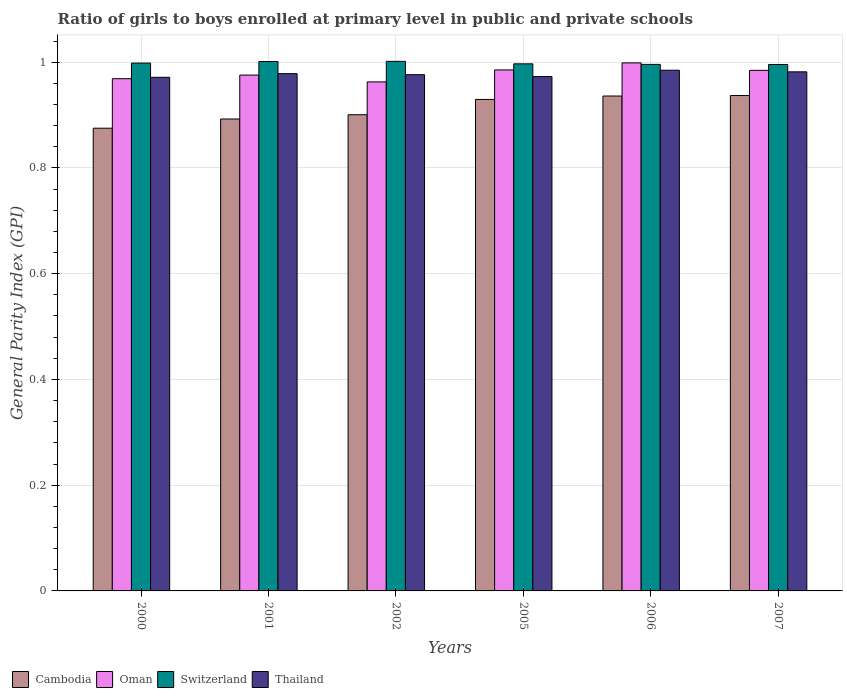How many different coloured bars are there?
Keep it short and to the point. 4. Are the number of bars per tick equal to the number of legend labels?
Your answer should be very brief. Yes. Are the number of bars on each tick of the X-axis equal?
Offer a very short reply. Yes. How many bars are there on the 3rd tick from the right?
Keep it short and to the point. 4. In how many cases, is the number of bars for a given year not equal to the number of legend labels?
Offer a very short reply. 0. What is the general parity index in Thailand in 2002?
Your answer should be compact. 0.98. Across all years, what is the maximum general parity index in Thailand?
Offer a very short reply. 0.98. Across all years, what is the minimum general parity index in Switzerland?
Your response must be concise. 1. In which year was the general parity index in Switzerland maximum?
Offer a very short reply. 2002. What is the total general parity index in Switzerland in the graph?
Keep it short and to the point. 5.99. What is the difference between the general parity index in Cambodia in 2005 and that in 2006?
Your answer should be compact. -0.01. What is the difference between the general parity index in Cambodia in 2007 and the general parity index in Thailand in 2001?
Your response must be concise. -0.04. What is the average general parity index in Cambodia per year?
Give a very brief answer. 0.91. In the year 2001, what is the difference between the general parity index in Switzerland and general parity index in Oman?
Offer a very short reply. 0.03. In how many years, is the general parity index in Thailand greater than 0.2?
Ensure brevity in your answer.  6. What is the ratio of the general parity index in Thailand in 2001 to that in 2002?
Make the answer very short. 1. What is the difference between the highest and the second highest general parity index in Oman?
Provide a short and direct response. 0.01. What is the difference between the highest and the lowest general parity index in Switzerland?
Provide a succinct answer. 0.01. In how many years, is the general parity index in Cambodia greater than the average general parity index in Cambodia taken over all years?
Your answer should be very brief. 3. Is the sum of the general parity index in Switzerland in 2002 and 2006 greater than the maximum general parity index in Cambodia across all years?
Give a very brief answer. Yes. Is it the case that in every year, the sum of the general parity index in Cambodia and general parity index in Oman is greater than the sum of general parity index in Thailand and general parity index in Switzerland?
Make the answer very short. No. What does the 1st bar from the left in 2001 represents?
Give a very brief answer. Cambodia. What does the 1st bar from the right in 2000 represents?
Make the answer very short. Thailand. How many bars are there?
Give a very brief answer. 24. Does the graph contain grids?
Make the answer very short. Yes. How are the legend labels stacked?
Provide a short and direct response. Horizontal. What is the title of the graph?
Your answer should be compact. Ratio of girls to boys enrolled at primary level in public and private schools. What is the label or title of the X-axis?
Give a very brief answer. Years. What is the label or title of the Y-axis?
Provide a short and direct response. General Parity Index (GPI). What is the General Parity Index (GPI) of Cambodia in 2000?
Ensure brevity in your answer.  0.88. What is the General Parity Index (GPI) of Oman in 2000?
Offer a terse response. 0.97. What is the General Parity Index (GPI) in Switzerland in 2000?
Your answer should be very brief. 1. What is the General Parity Index (GPI) in Thailand in 2000?
Your answer should be very brief. 0.97. What is the General Parity Index (GPI) in Cambodia in 2001?
Your answer should be compact. 0.89. What is the General Parity Index (GPI) in Oman in 2001?
Offer a terse response. 0.98. What is the General Parity Index (GPI) in Switzerland in 2001?
Ensure brevity in your answer.  1. What is the General Parity Index (GPI) in Thailand in 2001?
Your answer should be very brief. 0.98. What is the General Parity Index (GPI) of Cambodia in 2002?
Your answer should be very brief. 0.9. What is the General Parity Index (GPI) of Oman in 2002?
Provide a succinct answer. 0.96. What is the General Parity Index (GPI) of Switzerland in 2002?
Keep it short and to the point. 1. What is the General Parity Index (GPI) in Thailand in 2002?
Your answer should be very brief. 0.98. What is the General Parity Index (GPI) of Cambodia in 2005?
Ensure brevity in your answer.  0.93. What is the General Parity Index (GPI) of Oman in 2005?
Your answer should be very brief. 0.99. What is the General Parity Index (GPI) in Switzerland in 2005?
Make the answer very short. 1. What is the General Parity Index (GPI) of Thailand in 2005?
Provide a short and direct response. 0.97. What is the General Parity Index (GPI) in Cambodia in 2006?
Offer a very short reply. 0.94. What is the General Parity Index (GPI) in Oman in 2006?
Offer a very short reply. 1. What is the General Parity Index (GPI) of Switzerland in 2006?
Ensure brevity in your answer.  1. What is the General Parity Index (GPI) of Thailand in 2006?
Give a very brief answer. 0.98. What is the General Parity Index (GPI) in Cambodia in 2007?
Offer a very short reply. 0.94. What is the General Parity Index (GPI) of Oman in 2007?
Give a very brief answer. 0.98. What is the General Parity Index (GPI) in Switzerland in 2007?
Your answer should be compact. 1. What is the General Parity Index (GPI) of Thailand in 2007?
Your answer should be compact. 0.98. Across all years, what is the maximum General Parity Index (GPI) in Cambodia?
Give a very brief answer. 0.94. Across all years, what is the maximum General Parity Index (GPI) in Oman?
Offer a very short reply. 1. Across all years, what is the maximum General Parity Index (GPI) of Switzerland?
Offer a terse response. 1. Across all years, what is the maximum General Parity Index (GPI) of Thailand?
Your answer should be very brief. 0.98. Across all years, what is the minimum General Parity Index (GPI) of Cambodia?
Make the answer very short. 0.88. Across all years, what is the minimum General Parity Index (GPI) in Oman?
Your answer should be very brief. 0.96. Across all years, what is the minimum General Parity Index (GPI) in Switzerland?
Provide a succinct answer. 1. Across all years, what is the minimum General Parity Index (GPI) of Thailand?
Offer a terse response. 0.97. What is the total General Parity Index (GPI) in Cambodia in the graph?
Make the answer very short. 5.47. What is the total General Parity Index (GPI) of Oman in the graph?
Ensure brevity in your answer.  5.88. What is the total General Parity Index (GPI) in Switzerland in the graph?
Offer a terse response. 5.99. What is the total General Parity Index (GPI) in Thailand in the graph?
Provide a succinct answer. 5.87. What is the difference between the General Parity Index (GPI) in Cambodia in 2000 and that in 2001?
Offer a very short reply. -0.02. What is the difference between the General Parity Index (GPI) of Oman in 2000 and that in 2001?
Offer a very short reply. -0.01. What is the difference between the General Parity Index (GPI) of Switzerland in 2000 and that in 2001?
Offer a very short reply. -0. What is the difference between the General Parity Index (GPI) in Thailand in 2000 and that in 2001?
Your answer should be compact. -0.01. What is the difference between the General Parity Index (GPI) of Cambodia in 2000 and that in 2002?
Ensure brevity in your answer.  -0.03. What is the difference between the General Parity Index (GPI) of Oman in 2000 and that in 2002?
Provide a succinct answer. 0.01. What is the difference between the General Parity Index (GPI) of Switzerland in 2000 and that in 2002?
Your answer should be very brief. -0. What is the difference between the General Parity Index (GPI) in Thailand in 2000 and that in 2002?
Keep it short and to the point. -0.01. What is the difference between the General Parity Index (GPI) of Cambodia in 2000 and that in 2005?
Provide a succinct answer. -0.05. What is the difference between the General Parity Index (GPI) of Oman in 2000 and that in 2005?
Give a very brief answer. -0.02. What is the difference between the General Parity Index (GPI) in Switzerland in 2000 and that in 2005?
Make the answer very short. 0. What is the difference between the General Parity Index (GPI) of Thailand in 2000 and that in 2005?
Give a very brief answer. -0. What is the difference between the General Parity Index (GPI) of Cambodia in 2000 and that in 2006?
Keep it short and to the point. -0.06. What is the difference between the General Parity Index (GPI) of Oman in 2000 and that in 2006?
Keep it short and to the point. -0.03. What is the difference between the General Parity Index (GPI) in Switzerland in 2000 and that in 2006?
Give a very brief answer. 0. What is the difference between the General Parity Index (GPI) of Thailand in 2000 and that in 2006?
Your answer should be compact. -0.01. What is the difference between the General Parity Index (GPI) in Cambodia in 2000 and that in 2007?
Ensure brevity in your answer.  -0.06. What is the difference between the General Parity Index (GPI) in Oman in 2000 and that in 2007?
Your response must be concise. -0.02. What is the difference between the General Parity Index (GPI) in Switzerland in 2000 and that in 2007?
Make the answer very short. 0. What is the difference between the General Parity Index (GPI) of Thailand in 2000 and that in 2007?
Keep it short and to the point. -0.01. What is the difference between the General Parity Index (GPI) of Cambodia in 2001 and that in 2002?
Provide a succinct answer. -0.01. What is the difference between the General Parity Index (GPI) of Oman in 2001 and that in 2002?
Offer a terse response. 0.01. What is the difference between the General Parity Index (GPI) in Switzerland in 2001 and that in 2002?
Keep it short and to the point. -0. What is the difference between the General Parity Index (GPI) of Thailand in 2001 and that in 2002?
Make the answer very short. 0. What is the difference between the General Parity Index (GPI) in Cambodia in 2001 and that in 2005?
Keep it short and to the point. -0.04. What is the difference between the General Parity Index (GPI) in Oman in 2001 and that in 2005?
Provide a succinct answer. -0.01. What is the difference between the General Parity Index (GPI) in Switzerland in 2001 and that in 2005?
Your answer should be very brief. 0. What is the difference between the General Parity Index (GPI) in Thailand in 2001 and that in 2005?
Provide a short and direct response. 0.01. What is the difference between the General Parity Index (GPI) in Cambodia in 2001 and that in 2006?
Your answer should be compact. -0.04. What is the difference between the General Parity Index (GPI) of Oman in 2001 and that in 2006?
Give a very brief answer. -0.02. What is the difference between the General Parity Index (GPI) of Switzerland in 2001 and that in 2006?
Your answer should be very brief. 0.01. What is the difference between the General Parity Index (GPI) of Thailand in 2001 and that in 2006?
Keep it short and to the point. -0.01. What is the difference between the General Parity Index (GPI) of Cambodia in 2001 and that in 2007?
Your response must be concise. -0.04. What is the difference between the General Parity Index (GPI) of Oman in 2001 and that in 2007?
Provide a short and direct response. -0.01. What is the difference between the General Parity Index (GPI) in Switzerland in 2001 and that in 2007?
Keep it short and to the point. 0.01. What is the difference between the General Parity Index (GPI) of Thailand in 2001 and that in 2007?
Provide a succinct answer. -0. What is the difference between the General Parity Index (GPI) of Cambodia in 2002 and that in 2005?
Offer a terse response. -0.03. What is the difference between the General Parity Index (GPI) of Oman in 2002 and that in 2005?
Your answer should be compact. -0.02. What is the difference between the General Parity Index (GPI) in Switzerland in 2002 and that in 2005?
Your response must be concise. 0. What is the difference between the General Parity Index (GPI) of Thailand in 2002 and that in 2005?
Give a very brief answer. 0. What is the difference between the General Parity Index (GPI) in Cambodia in 2002 and that in 2006?
Give a very brief answer. -0.04. What is the difference between the General Parity Index (GPI) of Oman in 2002 and that in 2006?
Give a very brief answer. -0.04. What is the difference between the General Parity Index (GPI) in Switzerland in 2002 and that in 2006?
Give a very brief answer. 0.01. What is the difference between the General Parity Index (GPI) of Thailand in 2002 and that in 2006?
Offer a very short reply. -0.01. What is the difference between the General Parity Index (GPI) of Cambodia in 2002 and that in 2007?
Provide a succinct answer. -0.04. What is the difference between the General Parity Index (GPI) in Oman in 2002 and that in 2007?
Your answer should be compact. -0.02. What is the difference between the General Parity Index (GPI) in Switzerland in 2002 and that in 2007?
Ensure brevity in your answer.  0.01. What is the difference between the General Parity Index (GPI) in Thailand in 2002 and that in 2007?
Offer a very short reply. -0.01. What is the difference between the General Parity Index (GPI) in Cambodia in 2005 and that in 2006?
Your answer should be very brief. -0.01. What is the difference between the General Parity Index (GPI) in Oman in 2005 and that in 2006?
Offer a very short reply. -0.01. What is the difference between the General Parity Index (GPI) of Switzerland in 2005 and that in 2006?
Offer a very short reply. 0. What is the difference between the General Parity Index (GPI) of Thailand in 2005 and that in 2006?
Give a very brief answer. -0.01. What is the difference between the General Parity Index (GPI) in Cambodia in 2005 and that in 2007?
Your answer should be compact. -0.01. What is the difference between the General Parity Index (GPI) in Oman in 2005 and that in 2007?
Give a very brief answer. 0. What is the difference between the General Parity Index (GPI) of Switzerland in 2005 and that in 2007?
Your answer should be very brief. 0. What is the difference between the General Parity Index (GPI) in Thailand in 2005 and that in 2007?
Your answer should be compact. -0.01. What is the difference between the General Parity Index (GPI) of Cambodia in 2006 and that in 2007?
Your answer should be very brief. -0. What is the difference between the General Parity Index (GPI) of Oman in 2006 and that in 2007?
Make the answer very short. 0.01. What is the difference between the General Parity Index (GPI) in Thailand in 2006 and that in 2007?
Ensure brevity in your answer.  0. What is the difference between the General Parity Index (GPI) in Cambodia in 2000 and the General Parity Index (GPI) in Oman in 2001?
Your response must be concise. -0.1. What is the difference between the General Parity Index (GPI) of Cambodia in 2000 and the General Parity Index (GPI) of Switzerland in 2001?
Offer a terse response. -0.13. What is the difference between the General Parity Index (GPI) in Cambodia in 2000 and the General Parity Index (GPI) in Thailand in 2001?
Offer a terse response. -0.1. What is the difference between the General Parity Index (GPI) in Oman in 2000 and the General Parity Index (GPI) in Switzerland in 2001?
Offer a terse response. -0.03. What is the difference between the General Parity Index (GPI) in Oman in 2000 and the General Parity Index (GPI) in Thailand in 2001?
Offer a very short reply. -0.01. What is the difference between the General Parity Index (GPI) of Switzerland in 2000 and the General Parity Index (GPI) of Thailand in 2001?
Your answer should be very brief. 0.02. What is the difference between the General Parity Index (GPI) in Cambodia in 2000 and the General Parity Index (GPI) in Oman in 2002?
Offer a terse response. -0.09. What is the difference between the General Parity Index (GPI) of Cambodia in 2000 and the General Parity Index (GPI) of Switzerland in 2002?
Provide a succinct answer. -0.13. What is the difference between the General Parity Index (GPI) of Cambodia in 2000 and the General Parity Index (GPI) of Thailand in 2002?
Your response must be concise. -0.1. What is the difference between the General Parity Index (GPI) in Oman in 2000 and the General Parity Index (GPI) in Switzerland in 2002?
Provide a short and direct response. -0.03. What is the difference between the General Parity Index (GPI) in Oman in 2000 and the General Parity Index (GPI) in Thailand in 2002?
Offer a very short reply. -0.01. What is the difference between the General Parity Index (GPI) of Switzerland in 2000 and the General Parity Index (GPI) of Thailand in 2002?
Your answer should be compact. 0.02. What is the difference between the General Parity Index (GPI) in Cambodia in 2000 and the General Parity Index (GPI) in Oman in 2005?
Your answer should be compact. -0.11. What is the difference between the General Parity Index (GPI) of Cambodia in 2000 and the General Parity Index (GPI) of Switzerland in 2005?
Your response must be concise. -0.12. What is the difference between the General Parity Index (GPI) of Cambodia in 2000 and the General Parity Index (GPI) of Thailand in 2005?
Offer a very short reply. -0.1. What is the difference between the General Parity Index (GPI) of Oman in 2000 and the General Parity Index (GPI) of Switzerland in 2005?
Your response must be concise. -0.03. What is the difference between the General Parity Index (GPI) of Oman in 2000 and the General Parity Index (GPI) of Thailand in 2005?
Offer a terse response. -0. What is the difference between the General Parity Index (GPI) in Switzerland in 2000 and the General Parity Index (GPI) in Thailand in 2005?
Offer a very short reply. 0.03. What is the difference between the General Parity Index (GPI) of Cambodia in 2000 and the General Parity Index (GPI) of Oman in 2006?
Provide a short and direct response. -0.12. What is the difference between the General Parity Index (GPI) of Cambodia in 2000 and the General Parity Index (GPI) of Switzerland in 2006?
Give a very brief answer. -0.12. What is the difference between the General Parity Index (GPI) in Cambodia in 2000 and the General Parity Index (GPI) in Thailand in 2006?
Keep it short and to the point. -0.11. What is the difference between the General Parity Index (GPI) in Oman in 2000 and the General Parity Index (GPI) in Switzerland in 2006?
Make the answer very short. -0.03. What is the difference between the General Parity Index (GPI) of Oman in 2000 and the General Parity Index (GPI) of Thailand in 2006?
Give a very brief answer. -0.02. What is the difference between the General Parity Index (GPI) in Switzerland in 2000 and the General Parity Index (GPI) in Thailand in 2006?
Provide a short and direct response. 0.01. What is the difference between the General Parity Index (GPI) of Cambodia in 2000 and the General Parity Index (GPI) of Oman in 2007?
Give a very brief answer. -0.11. What is the difference between the General Parity Index (GPI) in Cambodia in 2000 and the General Parity Index (GPI) in Switzerland in 2007?
Offer a terse response. -0.12. What is the difference between the General Parity Index (GPI) of Cambodia in 2000 and the General Parity Index (GPI) of Thailand in 2007?
Offer a very short reply. -0.11. What is the difference between the General Parity Index (GPI) in Oman in 2000 and the General Parity Index (GPI) in Switzerland in 2007?
Make the answer very short. -0.03. What is the difference between the General Parity Index (GPI) in Oman in 2000 and the General Parity Index (GPI) in Thailand in 2007?
Offer a terse response. -0.01. What is the difference between the General Parity Index (GPI) in Switzerland in 2000 and the General Parity Index (GPI) in Thailand in 2007?
Provide a short and direct response. 0.02. What is the difference between the General Parity Index (GPI) in Cambodia in 2001 and the General Parity Index (GPI) in Oman in 2002?
Offer a very short reply. -0.07. What is the difference between the General Parity Index (GPI) of Cambodia in 2001 and the General Parity Index (GPI) of Switzerland in 2002?
Your answer should be compact. -0.11. What is the difference between the General Parity Index (GPI) in Cambodia in 2001 and the General Parity Index (GPI) in Thailand in 2002?
Give a very brief answer. -0.08. What is the difference between the General Parity Index (GPI) in Oman in 2001 and the General Parity Index (GPI) in Switzerland in 2002?
Provide a succinct answer. -0.03. What is the difference between the General Parity Index (GPI) of Oman in 2001 and the General Parity Index (GPI) of Thailand in 2002?
Your response must be concise. -0. What is the difference between the General Parity Index (GPI) of Switzerland in 2001 and the General Parity Index (GPI) of Thailand in 2002?
Your answer should be compact. 0.02. What is the difference between the General Parity Index (GPI) in Cambodia in 2001 and the General Parity Index (GPI) in Oman in 2005?
Offer a very short reply. -0.09. What is the difference between the General Parity Index (GPI) of Cambodia in 2001 and the General Parity Index (GPI) of Switzerland in 2005?
Offer a terse response. -0.1. What is the difference between the General Parity Index (GPI) in Cambodia in 2001 and the General Parity Index (GPI) in Thailand in 2005?
Keep it short and to the point. -0.08. What is the difference between the General Parity Index (GPI) of Oman in 2001 and the General Parity Index (GPI) of Switzerland in 2005?
Your answer should be very brief. -0.02. What is the difference between the General Parity Index (GPI) of Oman in 2001 and the General Parity Index (GPI) of Thailand in 2005?
Your answer should be compact. 0. What is the difference between the General Parity Index (GPI) in Switzerland in 2001 and the General Parity Index (GPI) in Thailand in 2005?
Your answer should be very brief. 0.03. What is the difference between the General Parity Index (GPI) in Cambodia in 2001 and the General Parity Index (GPI) in Oman in 2006?
Your response must be concise. -0.11. What is the difference between the General Parity Index (GPI) in Cambodia in 2001 and the General Parity Index (GPI) in Switzerland in 2006?
Keep it short and to the point. -0.1. What is the difference between the General Parity Index (GPI) of Cambodia in 2001 and the General Parity Index (GPI) of Thailand in 2006?
Make the answer very short. -0.09. What is the difference between the General Parity Index (GPI) in Oman in 2001 and the General Parity Index (GPI) in Switzerland in 2006?
Your response must be concise. -0.02. What is the difference between the General Parity Index (GPI) in Oman in 2001 and the General Parity Index (GPI) in Thailand in 2006?
Your answer should be compact. -0.01. What is the difference between the General Parity Index (GPI) in Switzerland in 2001 and the General Parity Index (GPI) in Thailand in 2006?
Your response must be concise. 0.02. What is the difference between the General Parity Index (GPI) of Cambodia in 2001 and the General Parity Index (GPI) of Oman in 2007?
Provide a short and direct response. -0.09. What is the difference between the General Parity Index (GPI) of Cambodia in 2001 and the General Parity Index (GPI) of Switzerland in 2007?
Your answer should be compact. -0.1. What is the difference between the General Parity Index (GPI) in Cambodia in 2001 and the General Parity Index (GPI) in Thailand in 2007?
Offer a very short reply. -0.09. What is the difference between the General Parity Index (GPI) of Oman in 2001 and the General Parity Index (GPI) of Switzerland in 2007?
Your answer should be very brief. -0.02. What is the difference between the General Parity Index (GPI) of Oman in 2001 and the General Parity Index (GPI) of Thailand in 2007?
Your answer should be very brief. -0.01. What is the difference between the General Parity Index (GPI) in Switzerland in 2001 and the General Parity Index (GPI) in Thailand in 2007?
Keep it short and to the point. 0.02. What is the difference between the General Parity Index (GPI) of Cambodia in 2002 and the General Parity Index (GPI) of Oman in 2005?
Make the answer very short. -0.08. What is the difference between the General Parity Index (GPI) in Cambodia in 2002 and the General Parity Index (GPI) in Switzerland in 2005?
Ensure brevity in your answer.  -0.1. What is the difference between the General Parity Index (GPI) in Cambodia in 2002 and the General Parity Index (GPI) in Thailand in 2005?
Offer a very short reply. -0.07. What is the difference between the General Parity Index (GPI) in Oman in 2002 and the General Parity Index (GPI) in Switzerland in 2005?
Provide a succinct answer. -0.03. What is the difference between the General Parity Index (GPI) of Oman in 2002 and the General Parity Index (GPI) of Thailand in 2005?
Your answer should be very brief. -0.01. What is the difference between the General Parity Index (GPI) of Switzerland in 2002 and the General Parity Index (GPI) of Thailand in 2005?
Offer a very short reply. 0.03. What is the difference between the General Parity Index (GPI) in Cambodia in 2002 and the General Parity Index (GPI) in Oman in 2006?
Your response must be concise. -0.1. What is the difference between the General Parity Index (GPI) of Cambodia in 2002 and the General Parity Index (GPI) of Switzerland in 2006?
Your answer should be compact. -0.1. What is the difference between the General Parity Index (GPI) in Cambodia in 2002 and the General Parity Index (GPI) in Thailand in 2006?
Keep it short and to the point. -0.08. What is the difference between the General Parity Index (GPI) in Oman in 2002 and the General Parity Index (GPI) in Switzerland in 2006?
Provide a short and direct response. -0.03. What is the difference between the General Parity Index (GPI) in Oman in 2002 and the General Parity Index (GPI) in Thailand in 2006?
Give a very brief answer. -0.02. What is the difference between the General Parity Index (GPI) of Switzerland in 2002 and the General Parity Index (GPI) of Thailand in 2006?
Ensure brevity in your answer.  0.02. What is the difference between the General Parity Index (GPI) in Cambodia in 2002 and the General Parity Index (GPI) in Oman in 2007?
Keep it short and to the point. -0.08. What is the difference between the General Parity Index (GPI) in Cambodia in 2002 and the General Parity Index (GPI) in Switzerland in 2007?
Offer a terse response. -0.1. What is the difference between the General Parity Index (GPI) in Cambodia in 2002 and the General Parity Index (GPI) in Thailand in 2007?
Give a very brief answer. -0.08. What is the difference between the General Parity Index (GPI) in Oman in 2002 and the General Parity Index (GPI) in Switzerland in 2007?
Ensure brevity in your answer.  -0.03. What is the difference between the General Parity Index (GPI) in Oman in 2002 and the General Parity Index (GPI) in Thailand in 2007?
Offer a very short reply. -0.02. What is the difference between the General Parity Index (GPI) in Switzerland in 2002 and the General Parity Index (GPI) in Thailand in 2007?
Your response must be concise. 0.02. What is the difference between the General Parity Index (GPI) of Cambodia in 2005 and the General Parity Index (GPI) of Oman in 2006?
Give a very brief answer. -0.07. What is the difference between the General Parity Index (GPI) of Cambodia in 2005 and the General Parity Index (GPI) of Switzerland in 2006?
Make the answer very short. -0.07. What is the difference between the General Parity Index (GPI) of Cambodia in 2005 and the General Parity Index (GPI) of Thailand in 2006?
Provide a short and direct response. -0.06. What is the difference between the General Parity Index (GPI) of Oman in 2005 and the General Parity Index (GPI) of Switzerland in 2006?
Make the answer very short. -0.01. What is the difference between the General Parity Index (GPI) of Oman in 2005 and the General Parity Index (GPI) of Thailand in 2006?
Provide a succinct answer. 0. What is the difference between the General Parity Index (GPI) of Switzerland in 2005 and the General Parity Index (GPI) of Thailand in 2006?
Ensure brevity in your answer.  0.01. What is the difference between the General Parity Index (GPI) of Cambodia in 2005 and the General Parity Index (GPI) of Oman in 2007?
Offer a terse response. -0.06. What is the difference between the General Parity Index (GPI) of Cambodia in 2005 and the General Parity Index (GPI) of Switzerland in 2007?
Provide a short and direct response. -0.07. What is the difference between the General Parity Index (GPI) of Cambodia in 2005 and the General Parity Index (GPI) of Thailand in 2007?
Your answer should be compact. -0.05. What is the difference between the General Parity Index (GPI) in Oman in 2005 and the General Parity Index (GPI) in Switzerland in 2007?
Make the answer very short. -0.01. What is the difference between the General Parity Index (GPI) of Oman in 2005 and the General Parity Index (GPI) of Thailand in 2007?
Provide a succinct answer. 0. What is the difference between the General Parity Index (GPI) in Switzerland in 2005 and the General Parity Index (GPI) in Thailand in 2007?
Ensure brevity in your answer.  0.02. What is the difference between the General Parity Index (GPI) of Cambodia in 2006 and the General Parity Index (GPI) of Oman in 2007?
Ensure brevity in your answer.  -0.05. What is the difference between the General Parity Index (GPI) in Cambodia in 2006 and the General Parity Index (GPI) in Switzerland in 2007?
Give a very brief answer. -0.06. What is the difference between the General Parity Index (GPI) in Cambodia in 2006 and the General Parity Index (GPI) in Thailand in 2007?
Offer a very short reply. -0.05. What is the difference between the General Parity Index (GPI) of Oman in 2006 and the General Parity Index (GPI) of Switzerland in 2007?
Offer a terse response. 0. What is the difference between the General Parity Index (GPI) of Oman in 2006 and the General Parity Index (GPI) of Thailand in 2007?
Your response must be concise. 0.02. What is the difference between the General Parity Index (GPI) in Switzerland in 2006 and the General Parity Index (GPI) in Thailand in 2007?
Offer a very short reply. 0.01. What is the average General Parity Index (GPI) of Cambodia per year?
Your answer should be compact. 0.91. What is the average General Parity Index (GPI) of Oman per year?
Make the answer very short. 0.98. What is the average General Parity Index (GPI) in Thailand per year?
Provide a short and direct response. 0.98. In the year 2000, what is the difference between the General Parity Index (GPI) of Cambodia and General Parity Index (GPI) of Oman?
Ensure brevity in your answer.  -0.09. In the year 2000, what is the difference between the General Parity Index (GPI) of Cambodia and General Parity Index (GPI) of Switzerland?
Provide a succinct answer. -0.12. In the year 2000, what is the difference between the General Parity Index (GPI) of Cambodia and General Parity Index (GPI) of Thailand?
Provide a short and direct response. -0.1. In the year 2000, what is the difference between the General Parity Index (GPI) in Oman and General Parity Index (GPI) in Switzerland?
Ensure brevity in your answer.  -0.03. In the year 2000, what is the difference between the General Parity Index (GPI) in Oman and General Parity Index (GPI) in Thailand?
Your answer should be compact. -0. In the year 2000, what is the difference between the General Parity Index (GPI) of Switzerland and General Parity Index (GPI) of Thailand?
Ensure brevity in your answer.  0.03. In the year 2001, what is the difference between the General Parity Index (GPI) in Cambodia and General Parity Index (GPI) in Oman?
Give a very brief answer. -0.08. In the year 2001, what is the difference between the General Parity Index (GPI) in Cambodia and General Parity Index (GPI) in Switzerland?
Ensure brevity in your answer.  -0.11. In the year 2001, what is the difference between the General Parity Index (GPI) in Cambodia and General Parity Index (GPI) in Thailand?
Offer a very short reply. -0.09. In the year 2001, what is the difference between the General Parity Index (GPI) of Oman and General Parity Index (GPI) of Switzerland?
Provide a short and direct response. -0.03. In the year 2001, what is the difference between the General Parity Index (GPI) in Oman and General Parity Index (GPI) in Thailand?
Provide a succinct answer. -0. In the year 2001, what is the difference between the General Parity Index (GPI) in Switzerland and General Parity Index (GPI) in Thailand?
Your response must be concise. 0.02. In the year 2002, what is the difference between the General Parity Index (GPI) of Cambodia and General Parity Index (GPI) of Oman?
Provide a succinct answer. -0.06. In the year 2002, what is the difference between the General Parity Index (GPI) of Cambodia and General Parity Index (GPI) of Switzerland?
Provide a short and direct response. -0.1. In the year 2002, what is the difference between the General Parity Index (GPI) in Cambodia and General Parity Index (GPI) in Thailand?
Your response must be concise. -0.08. In the year 2002, what is the difference between the General Parity Index (GPI) of Oman and General Parity Index (GPI) of Switzerland?
Your answer should be very brief. -0.04. In the year 2002, what is the difference between the General Parity Index (GPI) in Oman and General Parity Index (GPI) in Thailand?
Your answer should be very brief. -0.01. In the year 2002, what is the difference between the General Parity Index (GPI) in Switzerland and General Parity Index (GPI) in Thailand?
Give a very brief answer. 0.03. In the year 2005, what is the difference between the General Parity Index (GPI) of Cambodia and General Parity Index (GPI) of Oman?
Keep it short and to the point. -0.06. In the year 2005, what is the difference between the General Parity Index (GPI) of Cambodia and General Parity Index (GPI) of Switzerland?
Make the answer very short. -0.07. In the year 2005, what is the difference between the General Parity Index (GPI) of Cambodia and General Parity Index (GPI) of Thailand?
Your answer should be very brief. -0.04. In the year 2005, what is the difference between the General Parity Index (GPI) of Oman and General Parity Index (GPI) of Switzerland?
Offer a terse response. -0.01. In the year 2005, what is the difference between the General Parity Index (GPI) of Oman and General Parity Index (GPI) of Thailand?
Ensure brevity in your answer.  0.01. In the year 2005, what is the difference between the General Parity Index (GPI) of Switzerland and General Parity Index (GPI) of Thailand?
Your answer should be compact. 0.02. In the year 2006, what is the difference between the General Parity Index (GPI) of Cambodia and General Parity Index (GPI) of Oman?
Offer a terse response. -0.06. In the year 2006, what is the difference between the General Parity Index (GPI) in Cambodia and General Parity Index (GPI) in Switzerland?
Provide a succinct answer. -0.06. In the year 2006, what is the difference between the General Parity Index (GPI) of Cambodia and General Parity Index (GPI) of Thailand?
Offer a very short reply. -0.05. In the year 2006, what is the difference between the General Parity Index (GPI) of Oman and General Parity Index (GPI) of Switzerland?
Make the answer very short. 0. In the year 2006, what is the difference between the General Parity Index (GPI) of Oman and General Parity Index (GPI) of Thailand?
Offer a very short reply. 0.01. In the year 2006, what is the difference between the General Parity Index (GPI) in Switzerland and General Parity Index (GPI) in Thailand?
Your answer should be compact. 0.01. In the year 2007, what is the difference between the General Parity Index (GPI) in Cambodia and General Parity Index (GPI) in Oman?
Offer a very short reply. -0.05. In the year 2007, what is the difference between the General Parity Index (GPI) of Cambodia and General Parity Index (GPI) of Switzerland?
Your response must be concise. -0.06. In the year 2007, what is the difference between the General Parity Index (GPI) in Cambodia and General Parity Index (GPI) in Thailand?
Ensure brevity in your answer.  -0.04. In the year 2007, what is the difference between the General Parity Index (GPI) of Oman and General Parity Index (GPI) of Switzerland?
Make the answer very short. -0.01. In the year 2007, what is the difference between the General Parity Index (GPI) of Oman and General Parity Index (GPI) of Thailand?
Offer a terse response. 0. In the year 2007, what is the difference between the General Parity Index (GPI) of Switzerland and General Parity Index (GPI) of Thailand?
Your response must be concise. 0.01. What is the ratio of the General Parity Index (GPI) of Cambodia in 2000 to that in 2001?
Ensure brevity in your answer.  0.98. What is the ratio of the General Parity Index (GPI) of Switzerland in 2000 to that in 2001?
Provide a succinct answer. 1. What is the ratio of the General Parity Index (GPI) of Thailand in 2000 to that in 2001?
Provide a succinct answer. 0.99. What is the ratio of the General Parity Index (GPI) in Cambodia in 2000 to that in 2002?
Make the answer very short. 0.97. What is the ratio of the General Parity Index (GPI) of Switzerland in 2000 to that in 2002?
Keep it short and to the point. 1. What is the ratio of the General Parity Index (GPI) in Thailand in 2000 to that in 2002?
Ensure brevity in your answer.  0.99. What is the ratio of the General Parity Index (GPI) of Cambodia in 2000 to that in 2005?
Your answer should be compact. 0.94. What is the ratio of the General Parity Index (GPI) in Oman in 2000 to that in 2005?
Offer a very short reply. 0.98. What is the ratio of the General Parity Index (GPI) of Cambodia in 2000 to that in 2006?
Ensure brevity in your answer.  0.94. What is the ratio of the General Parity Index (GPI) in Oman in 2000 to that in 2006?
Provide a succinct answer. 0.97. What is the ratio of the General Parity Index (GPI) in Switzerland in 2000 to that in 2006?
Your answer should be compact. 1. What is the ratio of the General Parity Index (GPI) in Thailand in 2000 to that in 2006?
Your response must be concise. 0.99. What is the ratio of the General Parity Index (GPI) of Cambodia in 2000 to that in 2007?
Provide a succinct answer. 0.93. What is the ratio of the General Parity Index (GPI) of Oman in 2000 to that in 2007?
Provide a succinct answer. 0.98. What is the ratio of the General Parity Index (GPI) of Switzerland in 2000 to that in 2007?
Provide a succinct answer. 1. What is the ratio of the General Parity Index (GPI) in Thailand in 2000 to that in 2007?
Make the answer very short. 0.99. What is the ratio of the General Parity Index (GPI) of Oman in 2001 to that in 2002?
Provide a short and direct response. 1.01. What is the ratio of the General Parity Index (GPI) in Switzerland in 2001 to that in 2002?
Give a very brief answer. 1. What is the ratio of the General Parity Index (GPI) of Cambodia in 2001 to that in 2005?
Keep it short and to the point. 0.96. What is the ratio of the General Parity Index (GPI) in Switzerland in 2001 to that in 2005?
Make the answer very short. 1. What is the ratio of the General Parity Index (GPI) of Cambodia in 2001 to that in 2006?
Offer a very short reply. 0.95. What is the ratio of the General Parity Index (GPI) of Oman in 2001 to that in 2006?
Ensure brevity in your answer.  0.98. What is the ratio of the General Parity Index (GPI) in Switzerland in 2001 to that in 2006?
Offer a very short reply. 1.01. What is the ratio of the General Parity Index (GPI) of Thailand in 2001 to that in 2006?
Offer a very short reply. 0.99. What is the ratio of the General Parity Index (GPI) in Cambodia in 2001 to that in 2007?
Make the answer very short. 0.95. What is the ratio of the General Parity Index (GPI) of Oman in 2001 to that in 2007?
Offer a very short reply. 0.99. What is the ratio of the General Parity Index (GPI) in Switzerland in 2001 to that in 2007?
Provide a short and direct response. 1.01. What is the ratio of the General Parity Index (GPI) of Cambodia in 2002 to that in 2005?
Keep it short and to the point. 0.97. What is the ratio of the General Parity Index (GPI) of Switzerland in 2002 to that in 2005?
Offer a terse response. 1. What is the ratio of the General Parity Index (GPI) in Cambodia in 2002 to that in 2006?
Offer a terse response. 0.96. What is the ratio of the General Parity Index (GPI) in Oman in 2002 to that in 2006?
Provide a short and direct response. 0.96. What is the ratio of the General Parity Index (GPI) of Thailand in 2002 to that in 2006?
Your response must be concise. 0.99. What is the ratio of the General Parity Index (GPI) in Cambodia in 2002 to that in 2007?
Ensure brevity in your answer.  0.96. What is the ratio of the General Parity Index (GPI) of Oman in 2002 to that in 2007?
Your answer should be compact. 0.98. What is the ratio of the General Parity Index (GPI) in Switzerland in 2002 to that in 2007?
Offer a terse response. 1.01. What is the ratio of the General Parity Index (GPI) of Oman in 2005 to that in 2006?
Give a very brief answer. 0.99. What is the ratio of the General Parity Index (GPI) in Cambodia in 2005 to that in 2007?
Provide a succinct answer. 0.99. What is the ratio of the General Parity Index (GPI) of Oman in 2005 to that in 2007?
Provide a succinct answer. 1. What is the ratio of the General Parity Index (GPI) in Thailand in 2005 to that in 2007?
Your response must be concise. 0.99. What is the ratio of the General Parity Index (GPI) of Cambodia in 2006 to that in 2007?
Offer a very short reply. 1. What is the ratio of the General Parity Index (GPI) in Oman in 2006 to that in 2007?
Offer a very short reply. 1.01. What is the ratio of the General Parity Index (GPI) in Switzerland in 2006 to that in 2007?
Your answer should be very brief. 1. What is the difference between the highest and the second highest General Parity Index (GPI) in Cambodia?
Provide a short and direct response. 0. What is the difference between the highest and the second highest General Parity Index (GPI) of Oman?
Your response must be concise. 0.01. What is the difference between the highest and the second highest General Parity Index (GPI) of Switzerland?
Ensure brevity in your answer.  0. What is the difference between the highest and the second highest General Parity Index (GPI) of Thailand?
Your answer should be compact. 0. What is the difference between the highest and the lowest General Parity Index (GPI) of Cambodia?
Keep it short and to the point. 0.06. What is the difference between the highest and the lowest General Parity Index (GPI) in Oman?
Your response must be concise. 0.04. What is the difference between the highest and the lowest General Parity Index (GPI) in Switzerland?
Give a very brief answer. 0.01. What is the difference between the highest and the lowest General Parity Index (GPI) of Thailand?
Make the answer very short. 0.01. 